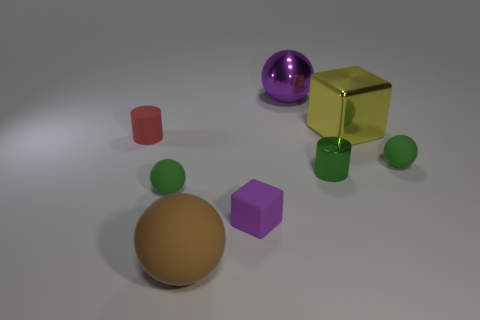What is the size of the sphere right of the large yellow metallic block?
Give a very brief answer. Small. There is a purple thing that is the same material as the big brown object; what is its size?
Keep it short and to the point. Small. How many small rubber balls are the same color as the small rubber cylinder?
Offer a very short reply. 0. Are there any tiny green rubber spheres?
Keep it short and to the point. Yes. Is the shape of the red matte thing the same as the purple thing that is in front of the metal ball?
Ensure brevity in your answer.  No. What is the color of the tiny cylinder that is behind the small green matte thing that is on the right side of the purple object behind the small matte cylinder?
Your response must be concise. Red. There is a red rubber cylinder; are there any purple metallic balls on the left side of it?
Offer a terse response. No. What is the size of the thing that is the same color as the small cube?
Provide a short and direct response. Large. Is there a yellow cube that has the same material as the small purple object?
Offer a very short reply. No. The matte cube has what color?
Provide a succinct answer. Purple. 